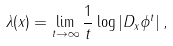<formula> <loc_0><loc_0><loc_500><loc_500>\lambda ( x ) = \lim _ { t \to \infty } \frac { 1 } { t } \log | D _ { x } \phi ^ { t } | \, ,</formula> 